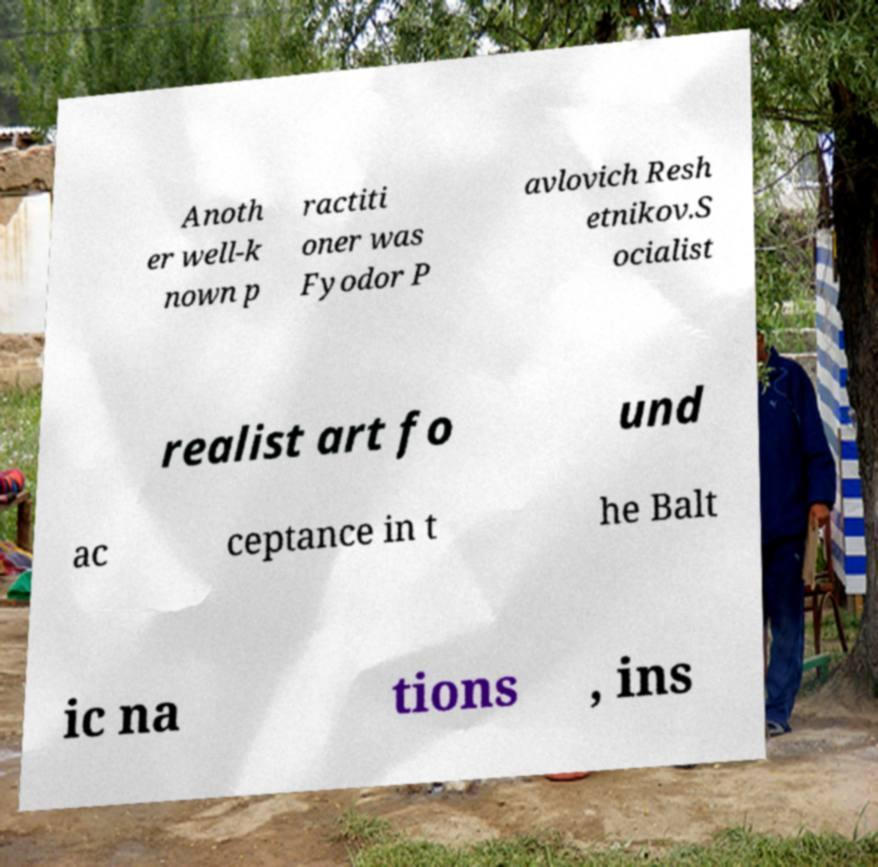Can you accurately transcribe the text from the provided image for me? Anoth er well-k nown p ractiti oner was Fyodor P avlovich Resh etnikov.S ocialist realist art fo und ac ceptance in t he Balt ic na tions , ins 